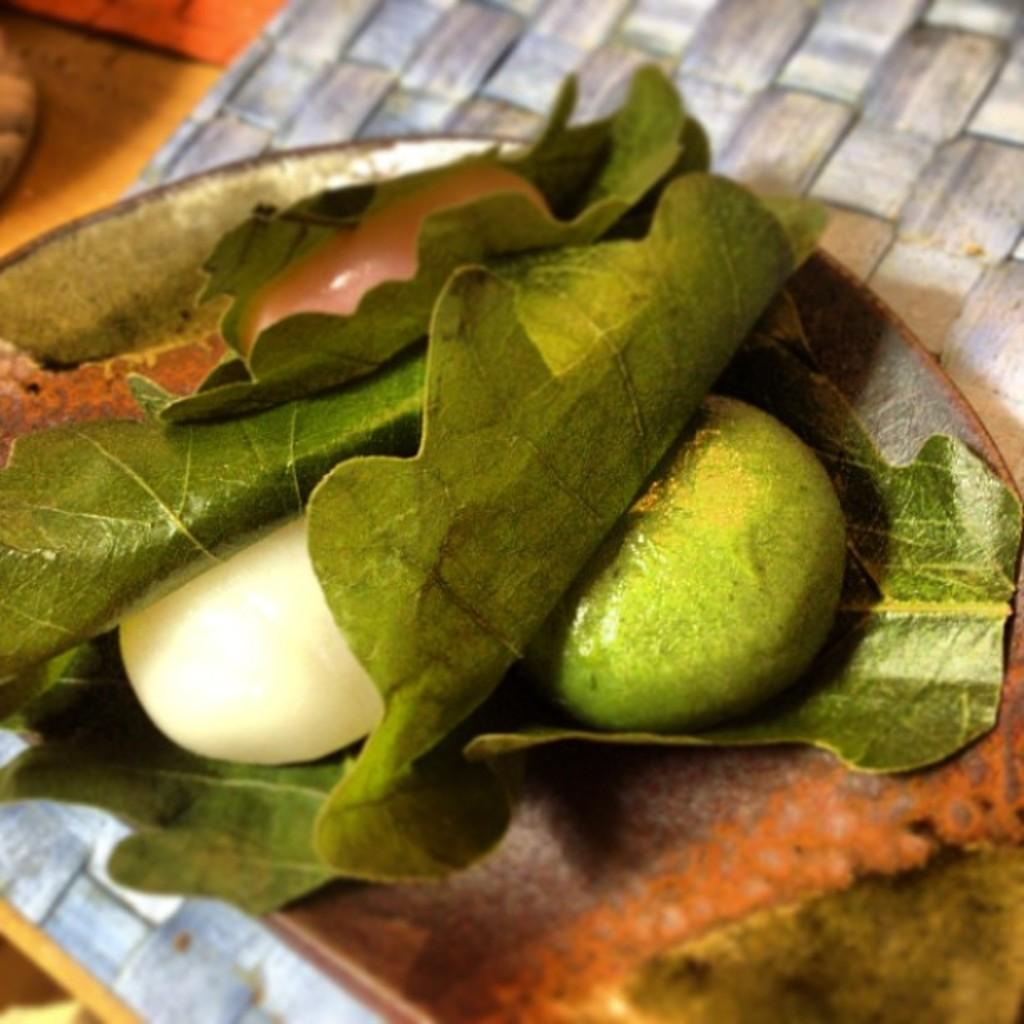What is on the plate that is visible in the image? The plate contains leaves and food ingredients. Where is the plate located in the image? The plate is placed on a table. What might be used to prepare or serve the food on the plate? The leaves and food ingredients on the plate are likely used for preparing or serving food. What type of hospital is visible in the image? There is no hospital present in the image; it features a plate with leaves and food ingredients on a table. Can you describe the haircut of the bears in the image? There are no bears present in the image, and therefore no haircuts can be described. 